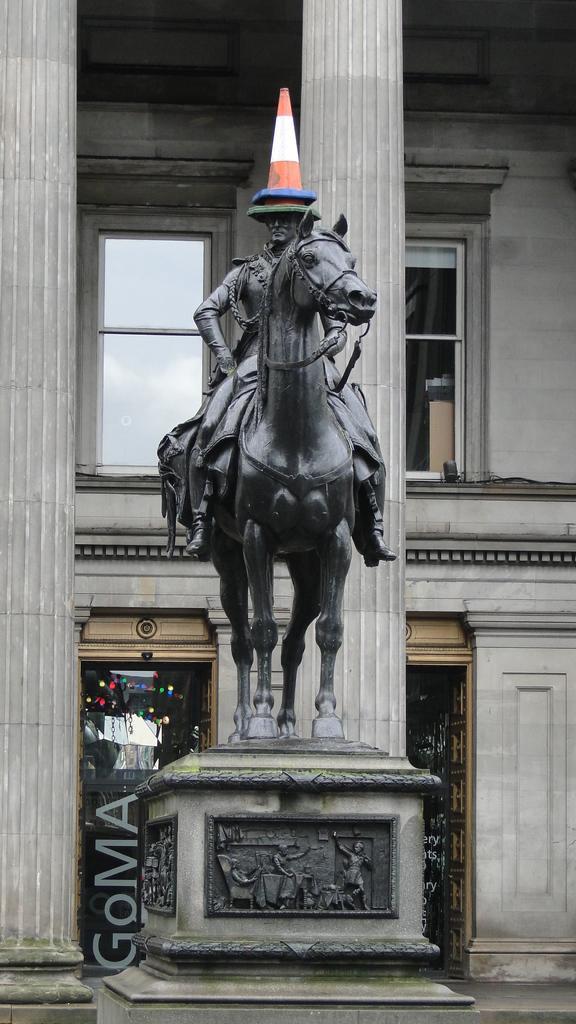In one or two sentences, can you explain what this image depicts? In this picture I can see a statue of a person sitting on the horse, there is a cone bar barricade on the person head, and in the background there is a building with pillars. 